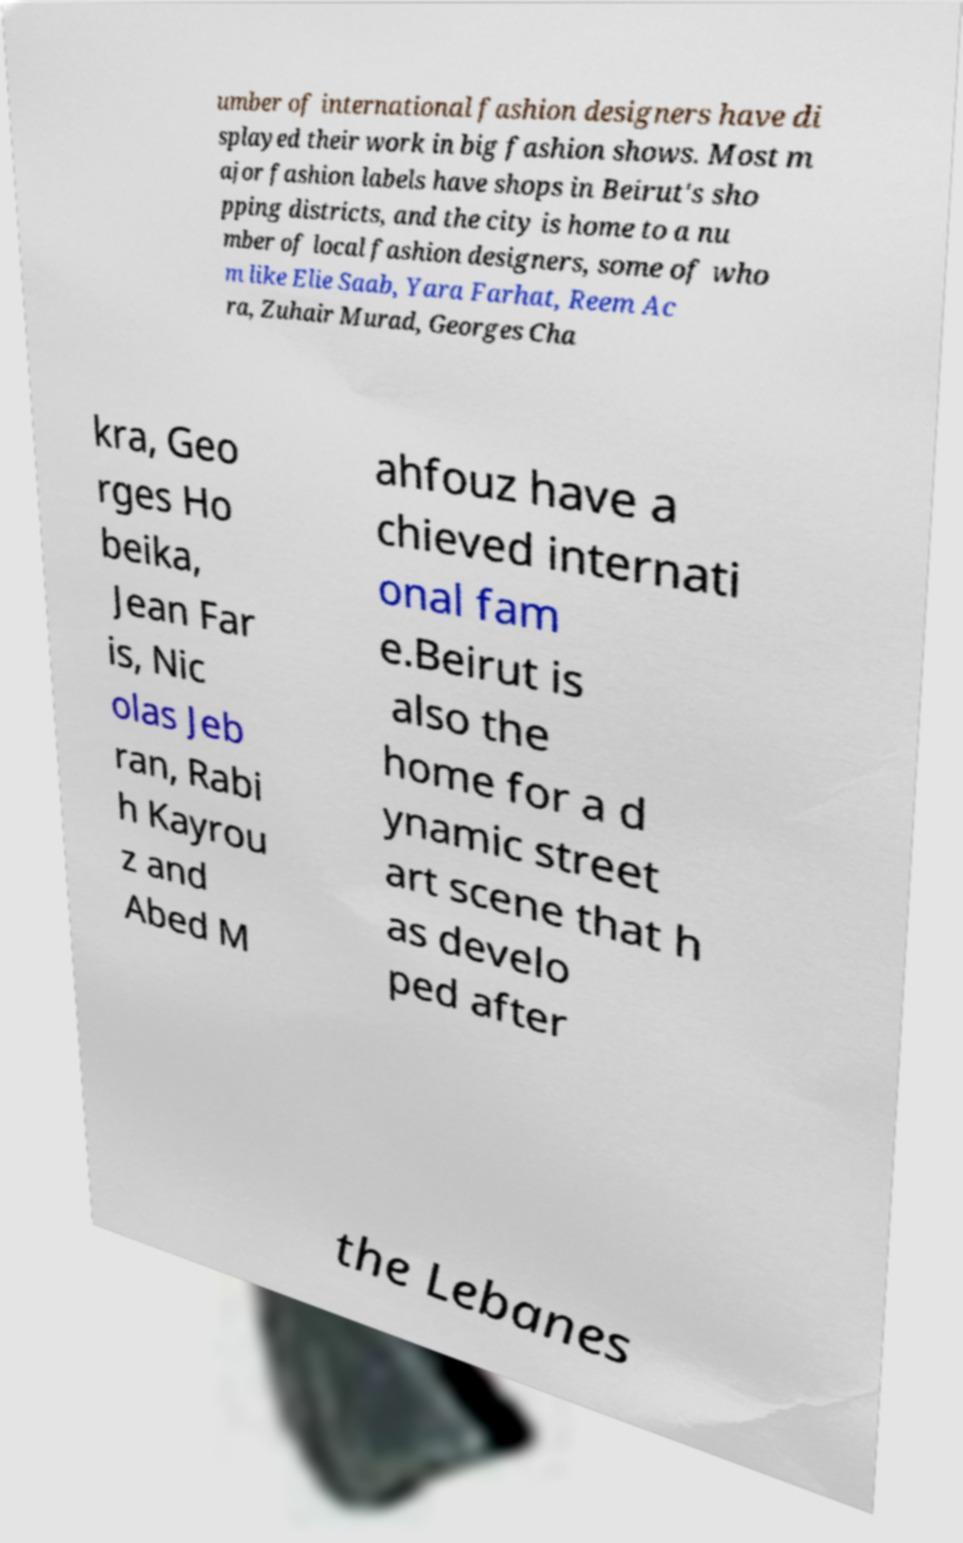Please read and relay the text visible in this image. What does it say? umber of international fashion designers have di splayed their work in big fashion shows. Most m ajor fashion labels have shops in Beirut's sho pping districts, and the city is home to a nu mber of local fashion designers, some of who m like Elie Saab, Yara Farhat, Reem Ac ra, Zuhair Murad, Georges Cha kra, Geo rges Ho beika, Jean Far is, Nic olas Jeb ran, Rabi h Kayrou z and Abed M ahfouz have a chieved internati onal fam e.Beirut is also the home for a d ynamic street art scene that h as develo ped after the Lebanes 